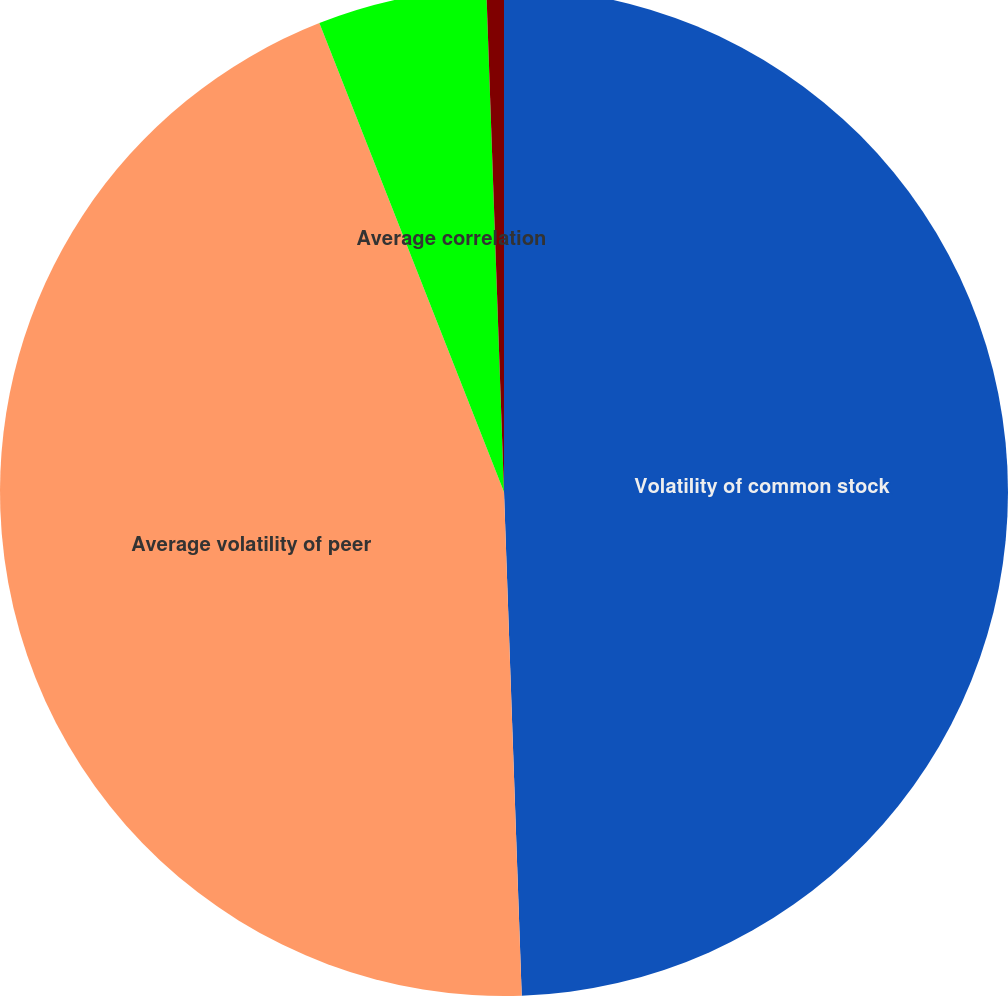Convert chart. <chart><loc_0><loc_0><loc_500><loc_500><pie_chart><fcel>Volatility of common stock<fcel>Average volatility of peer<fcel>Average correlation<fcel>Risk-free interest rate<nl><fcel>49.44%<fcel>44.59%<fcel>5.41%<fcel>0.56%<nl></chart> 